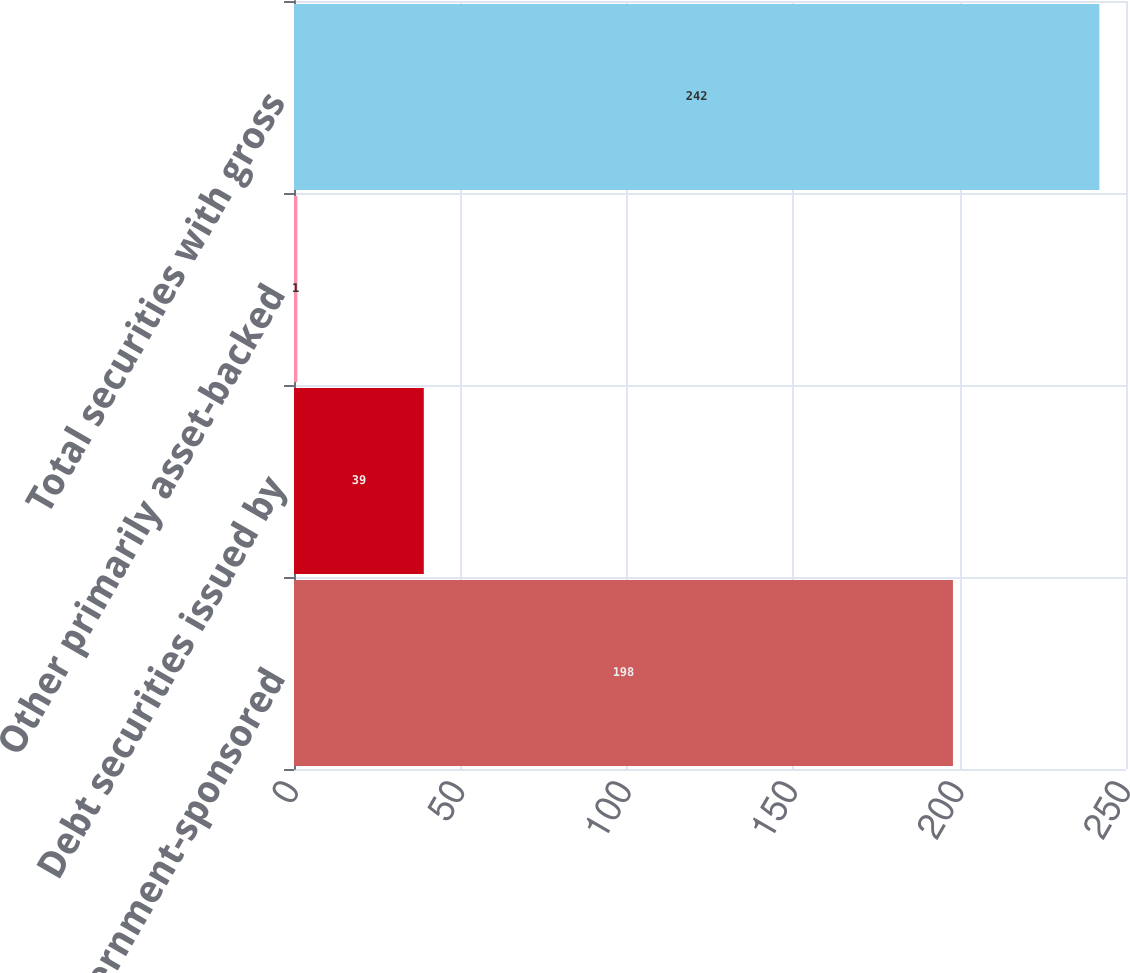Convert chart. <chart><loc_0><loc_0><loc_500><loc_500><bar_chart><fcel>US government-sponsored<fcel>Debt securities issued by<fcel>Other primarily asset-backed<fcel>Total securities with gross<nl><fcel>198<fcel>39<fcel>1<fcel>242<nl></chart> 